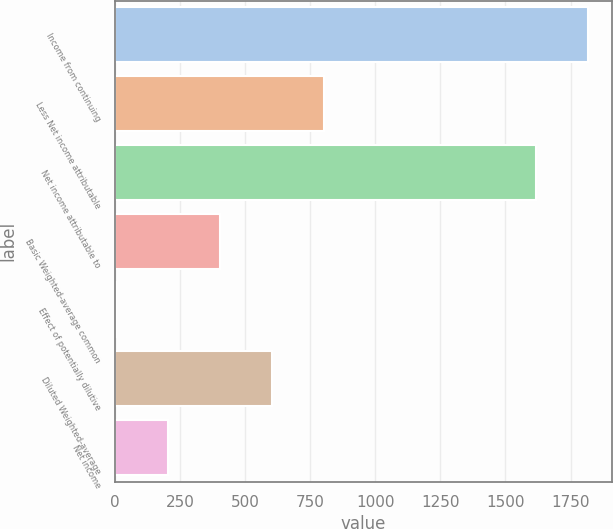Convert chart to OTSL. <chart><loc_0><loc_0><loc_500><loc_500><bar_chart><fcel>Income from continuing<fcel>Less Net income attributable<fcel>Net income attributable to<fcel>Basic Weighted-average common<fcel>Effect of potentially dilutive<fcel>Diluted Weighted-average<fcel>Net income<nl><fcel>1818.86<fcel>802.84<fcel>1619<fcel>403.12<fcel>3.4<fcel>602.98<fcel>203.26<nl></chart> 